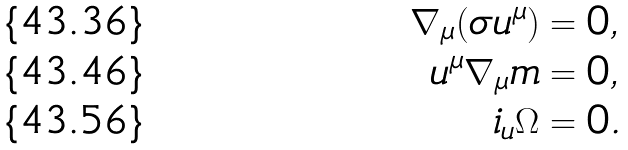<formula> <loc_0><loc_0><loc_500><loc_500>\nabla _ { \mu } ( \sigma u ^ { \mu } ) & = 0 , \\ u ^ { \mu } \nabla _ { \mu } m & = 0 , \\ i _ { u } \Omega & = 0 .</formula> 